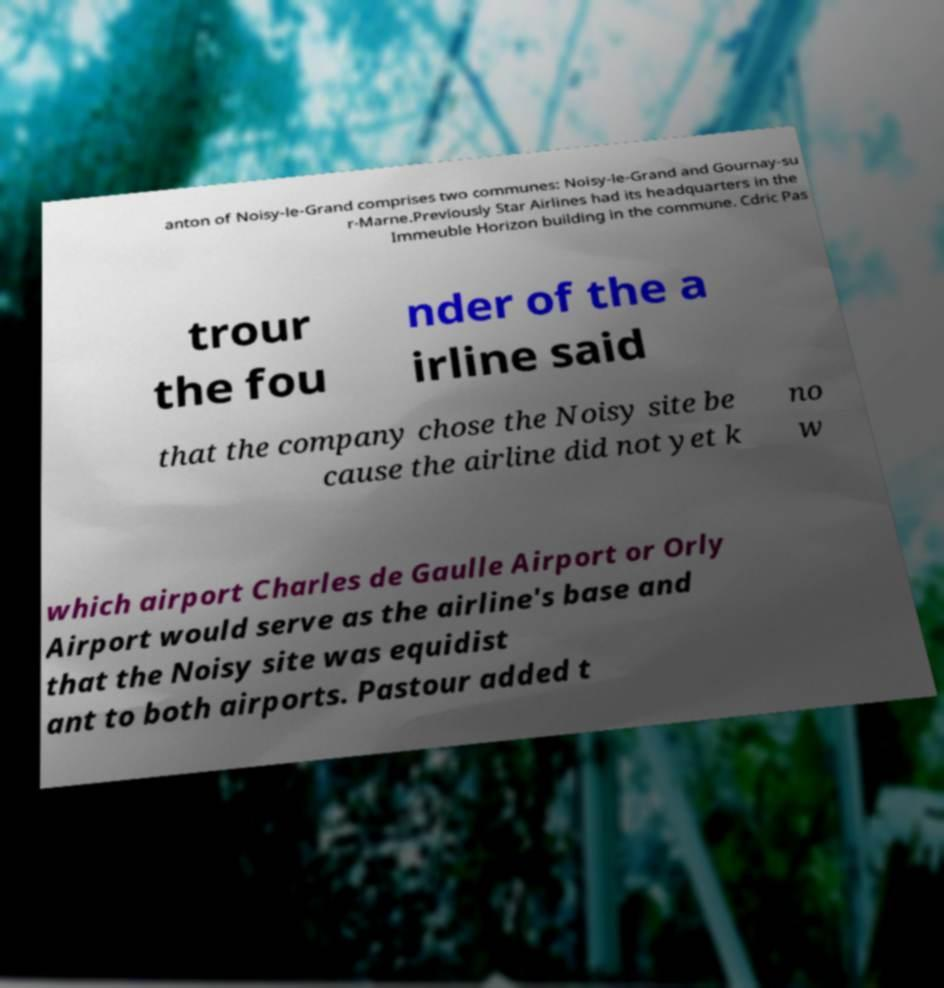Please identify and transcribe the text found in this image. anton of Noisy-le-Grand comprises two communes: Noisy-le-Grand and Gournay-su r-Marne.Previously Star Airlines had its headquarters in the Immeuble Horizon building in the commune. Cdric Pas trour the fou nder of the a irline said that the company chose the Noisy site be cause the airline did not yet k no w which airport Charles de Gaulle Airport or Orly Airport would serve as the airline's base and that the Noisy site was equidist ant to both airports. Pastour added t 